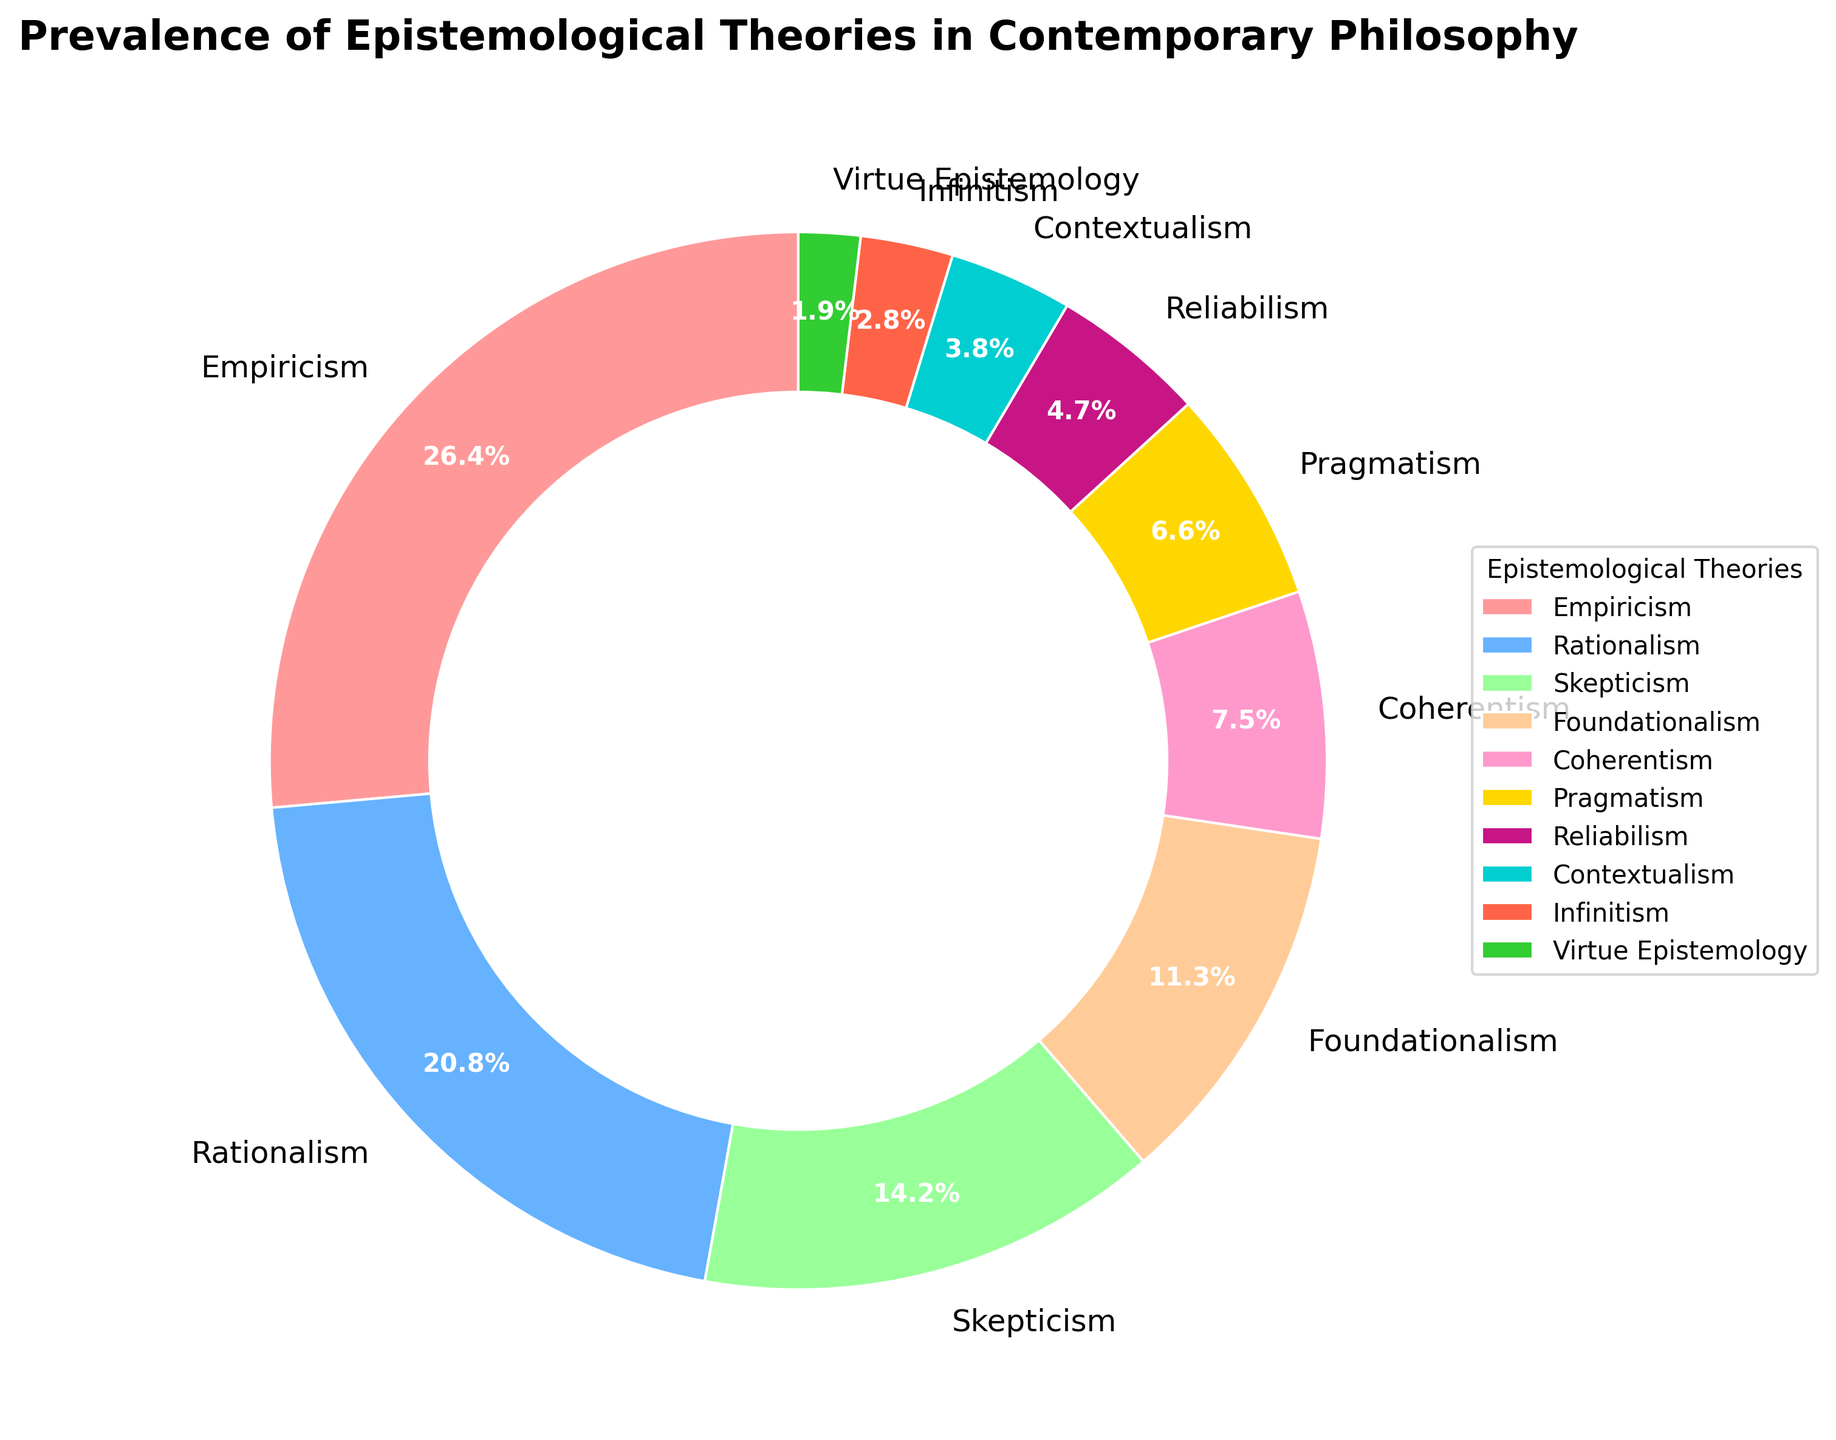What are the three most prevalent epistemological theories represented in the chart, and what is the total percentage of these three combined? The three most prevalent theories shown in the pie chart are Empiricism, Rationalism, and Skepticism. To find their combined total percentage, sum the respective percentages: Empiricism (28%), Rationalism (22%), and Skepticism (15%). Therefore, the total is 28% + 22% + 15% = 65%.
Answer: 65% Which epistemological theory has the least representation in the chart, and what is its percentage? The smallest segment in the pie chart is for Virtue Epistemology, which has a representation of 2%.
Answer: Virtue Epistemology, 2% Between Coherentism and Pragmatism, which theory has a higher representation, and by how much? According to the chart, Coherentism has 8% while Pragmatism has 7%. Subtracting the percentages, Coherentism has a higher representation by 8% - 7% = 1%.
Answer: Coherentism, 1% What is the difference in the sum of the percentages of Foundationalism and Reliabilism versus the sum of Contextualism and Infinitism? To find the sum of the percentages for Foundationalism and Reliabilism (12% and 5%), sum them: 12% + 5% = 17%. Similarly, for Contextualism and Infinitism (4% and 3%), sum them: 4% + 3% = 7%. The difference between these sums is 17% - 7% = 10%.
Answer: 10% What percentage of the chart is represented by theories that individually constitute less than 10%? Identify the theories individually constituting less than 10%, which are Skepticism (15%), Foundationalism (12%), Coherentism (8%), Pragmatism (7%), Reliabilism (5%), Contextualism (4%), Infinitism (3%), and Virtue Epistemology (2%). Calculate the sum: 8% + 7% + 5% + 4% + 3% + 2% = 29%.
Answer: 29% Which theories are represented by the three smallest segments in the chart, and what are their percentages combined? The three smallest segments represent Virtue Epistemology (2%), Infinitism (3%), and Contextualism (4%). Summing these percentages gives 2% + 3% + 4% = 9%.
Answer: Virtue Epistemology, Infinitism, Contextualism; 9% What is the ratio of the percentage representation of Empiricism to Coherentism? The percentage for Empiricism is 28% and for Coherentism is 8%. The ratio is 28% / 8% = 3.5.
Answer: 3.5 